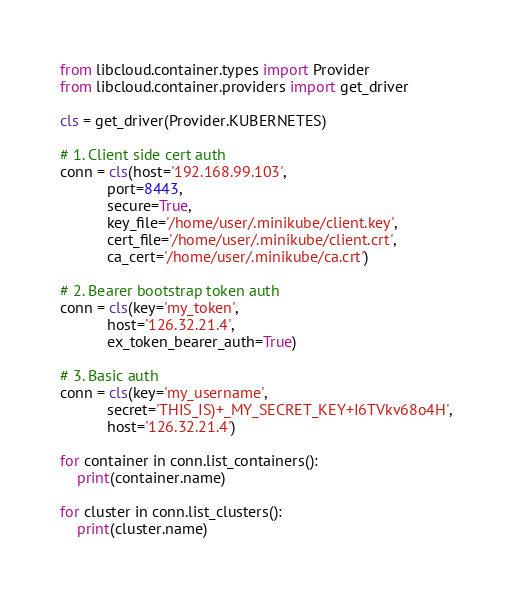<code> <loc_0><loc_0><loc_500><loc_500><_Python_>from libcloud.container.types import Provider
from libcloud.container.providers import get_driver

cls = get_driver(Provider.KUBERNETES)

# 1. Client side cert auth
conn = cls(host='192.168.99.103',
           port=8443,
           secure=True,
           key_file='/home/user/.minikube/client.key',
           cert_file='/home/user/.minikube/client.crt',
           ca_cert='/home/user/.minikube/ca.crt')

# 2. Bearer bootstrap token auth
conn = cls(key='my_token',
           host='126.32.21.4',
           ex_token_bearer_auth=True)

# 3. Basic auth
conn = cls(key='my_username',
           secret='THIS_IS)+_MY_SECRET_KEY+I6TVkv68o4H',
           host='126.32.21.4')

for container in conn.list_containers():
    print(container.name)

for cluster in conn.list_clusters():
    print(cluster.name)
</code> 